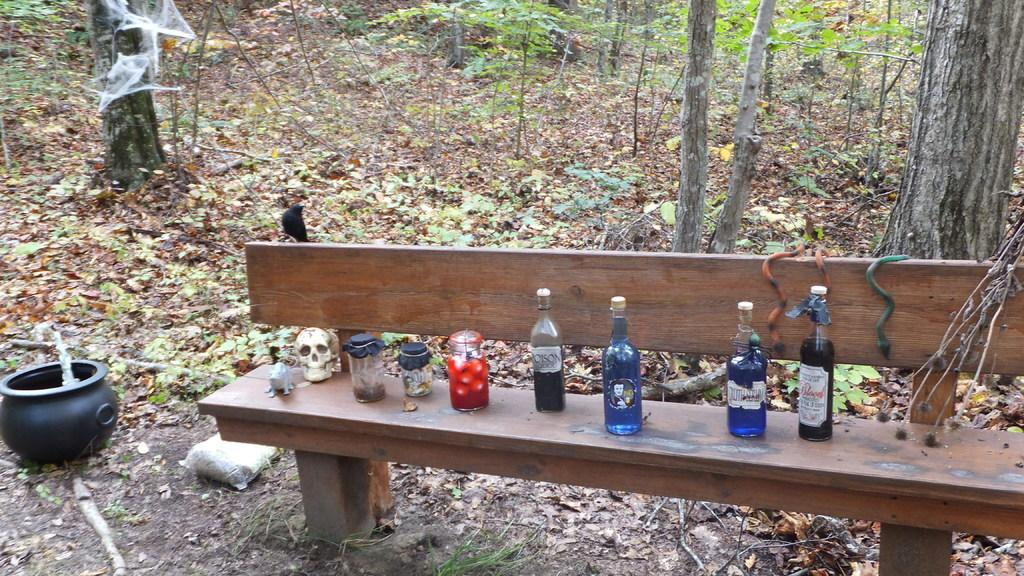What objects are on the bench in the image? There are bottles on the bench in the image. What is located to the left in the image? There is a bowl to the left in the image. What can be seen in the background of the image? There are trees and plants in the background of the image. What is present on the ground in the background of the image? Dry leaves are present on the ground in the background of the image. Where is the lamp placed in the image? There is no lamp present in the image. What type of desk can be seen in the image? There is no desk present in the image. 